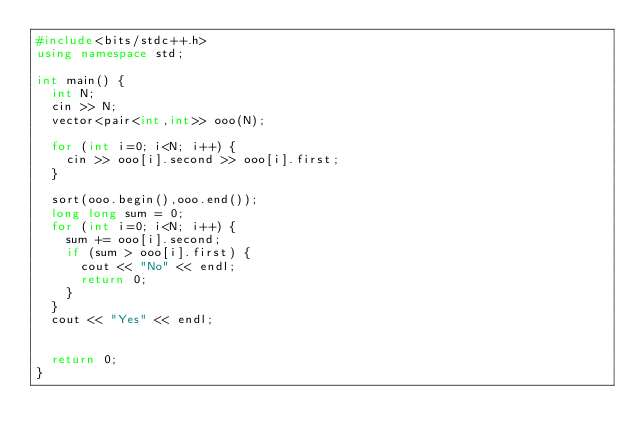Convert code to text. <code><loc_0><loc_0><loc_500><loc_500><_C++_>#include<bits/stdc++.h>
using namespace std;

int main() {
  int N;
  cin >> N;
  vector<pair<int,int>> ooo(N);
  
  for (int i=0; i<N; i++) {
    cin >> ooo[i].second >> ooo[i].first;
  }
  
  sort(ooo.begin(),ooo.end());
  long long sum = 0;
  for (int i=0; i<N; i++) {
    sum += ooo[i].second;
    if (sum > ooo[i].first) {
      cout << "No" << endl;
      return 0;
    }
  }
  cout << "Yes" << endl;
  
  
  return 0;
}</code> 